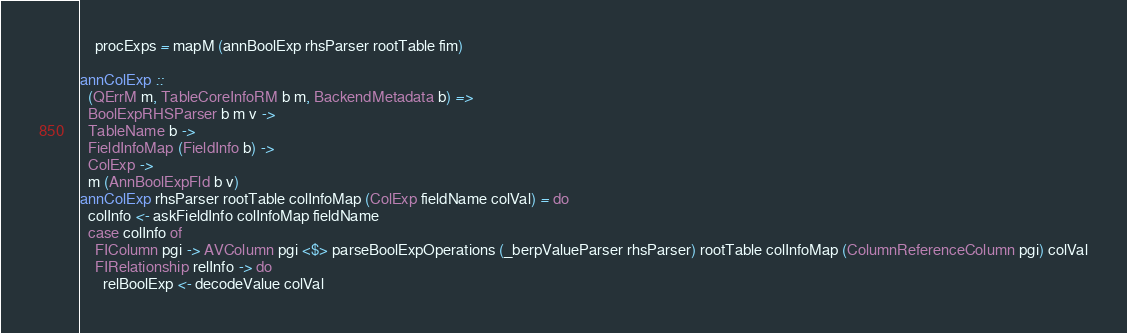Convert code to text. <code><loc_0><loc_0><loc_500><loc_500><_Haskell_>    procExps = mapM (annBoolExp rhsParser rootTable fim)

annColExp ::
  (QErrM m, TableCoreInfoRM b m, BackendMetadata b) =>
  BoolExpRHSParser b m v ->
  TableName b ->
  FieldInfoMap (FieldInfo b) ->
  ColExp ->
  m (AnnBoolExpFld b v)
annColExp rhsParser rootTable colInfoMap (ColExp fieldName colVal) = do
  colInfo <- askFieldInfo colInfoMap fieldName
  case colInfo of
    FIColumn pgi -> AVColumn pgi <$> parseBoolExpOperations (_berpValueParser rhsParser) rootTable colInfoMap (ColumnReferenceColumn pgi) colVal
    FIRelationship relInfo -> do
      relBoolExp <- decodeValue colVal</code> 